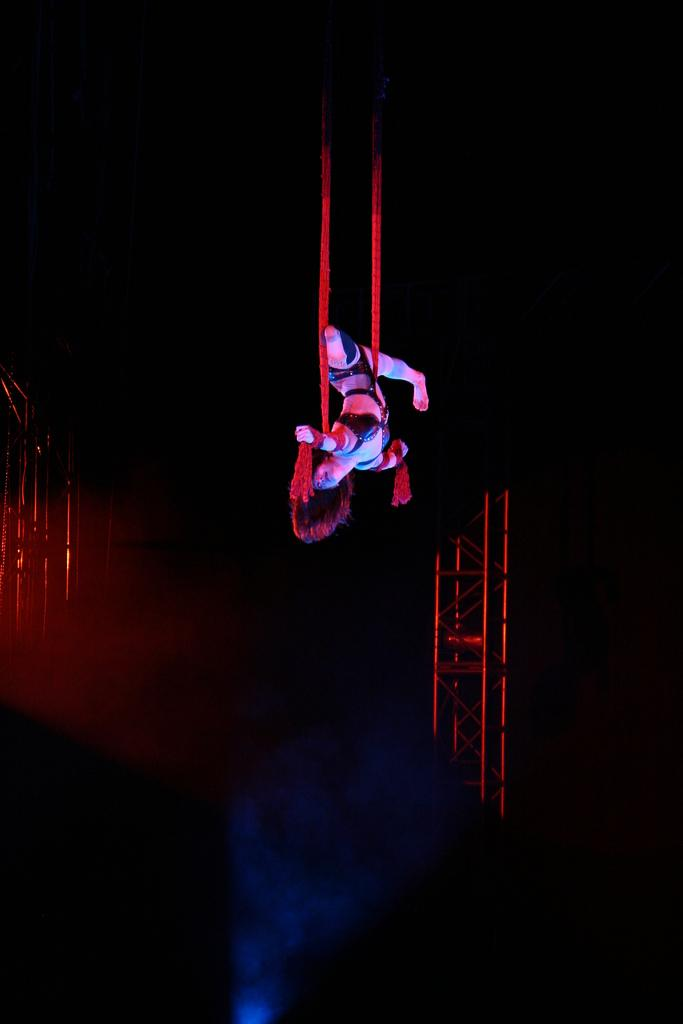Who is present in the image? There is a woman in the image. What is the woman's condition in the image? The woman is tied with ropes and in the air. What can be seen in the background of the image? There are poles in the background of the image. What color is the paint on the woman's finger in the image? There is no paint or finger mentioned in the image; the woman is tied with ropes and in the air. 